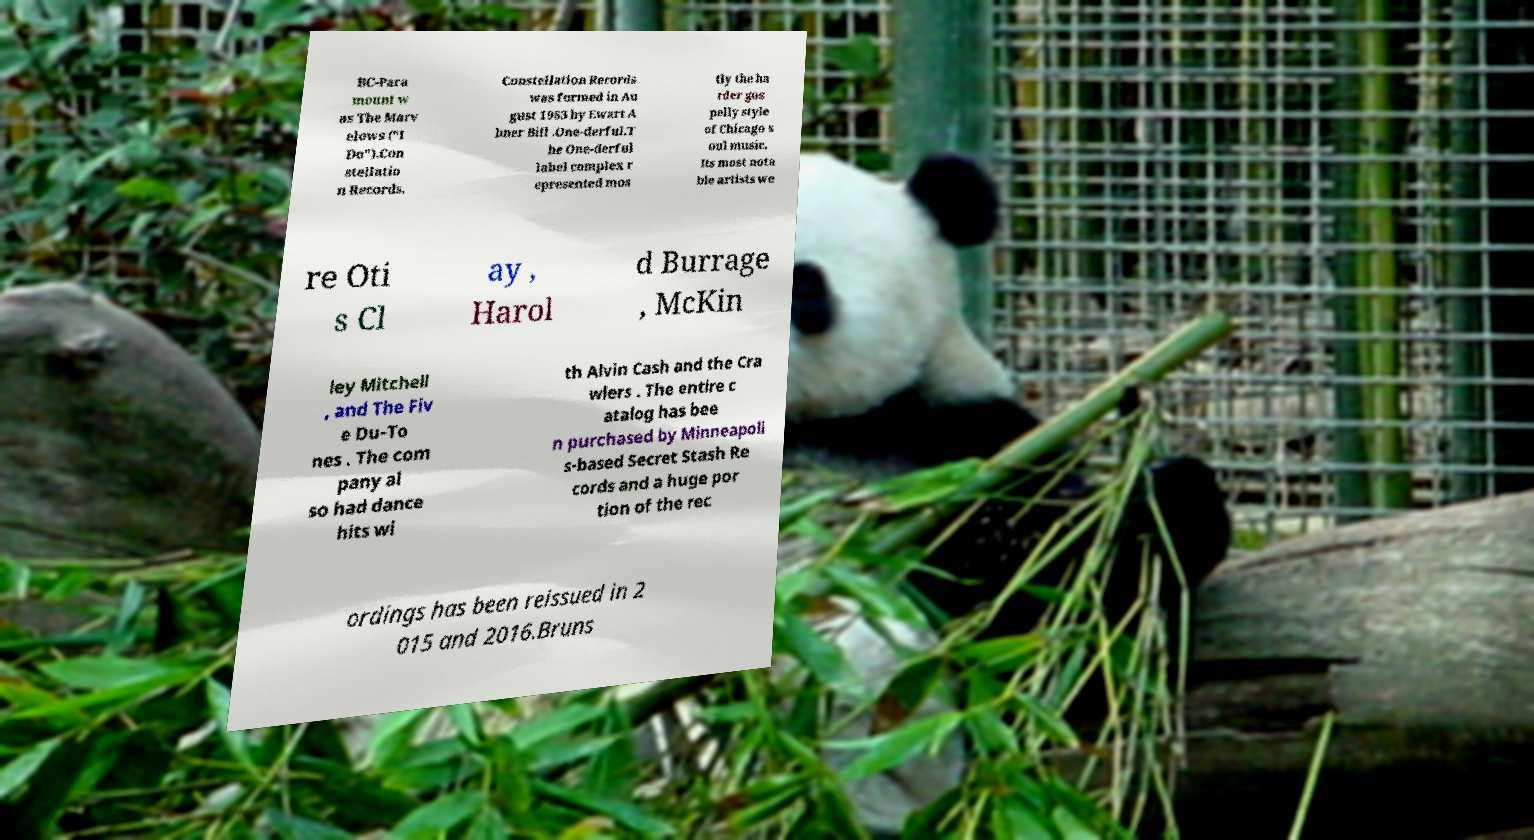Can you read and provide the text displayed in the image?This photo seems to have some interesting text. Can you extract and type it out for me? BC-Para mount w as The Marv elows ("I Do").Con stellatio n Records. Constellation Records was formed in Au gust 1963 by Ewart A bner Bill .One-derful.T he One-derful label complex r epresented mos tly the ha rder gos pelly style of Chicago s oul music. Its most nota ble artists we re Oti s Cl ay , Harol d Burrage , McKin ley Mitchell , and The Fiv e Du-To nes . The com pany al so had dance hits wi th Alvin Cash and the Cra wlers . The entire c atalog has bee n purchased by Minneapoli s-based Secret Stash Re cords and a huge por tion of the rec ordings has been reissued in 2 015 and 2016.Bruns 